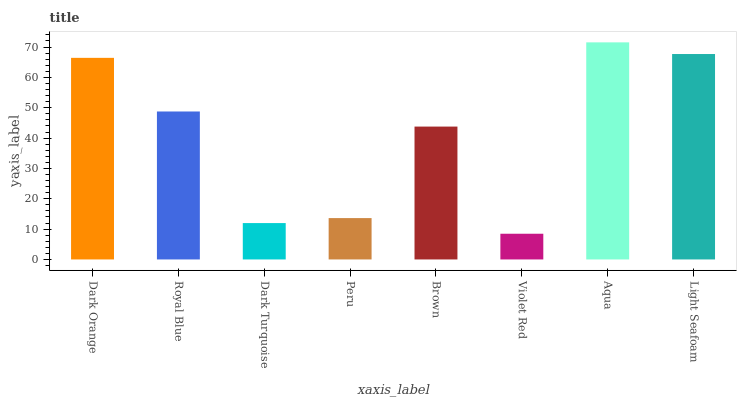Is Violet Red the minimum?
Answer yes or no. Yes. Is Aqua the maximum?
Answer yes or no. Yes. Is Royal Blue the minimum?
Answer yes or no. No. Is Royal Blue the maximum?
Answer yes or no. No. Is Dark Orange greater than Royal Blue?
Answer yes or no. Yes. Is Royal Blue less than Dark Orange?
Answer yes or no. Yes. Is Royal Blue greater than Dark Orange?
Answer yes or no. No. Is Dark Orange less than Royal Blue?
Answer yes or no. No. Is Royal Blue the high median?
Answer yes or no. Yes. Is Brown the low median?
Answer yes or no. Yes. Is Violet Red the high median?
Answer yes or no. No. Is Dark Orange the low median?
Answer yes or no. No. 